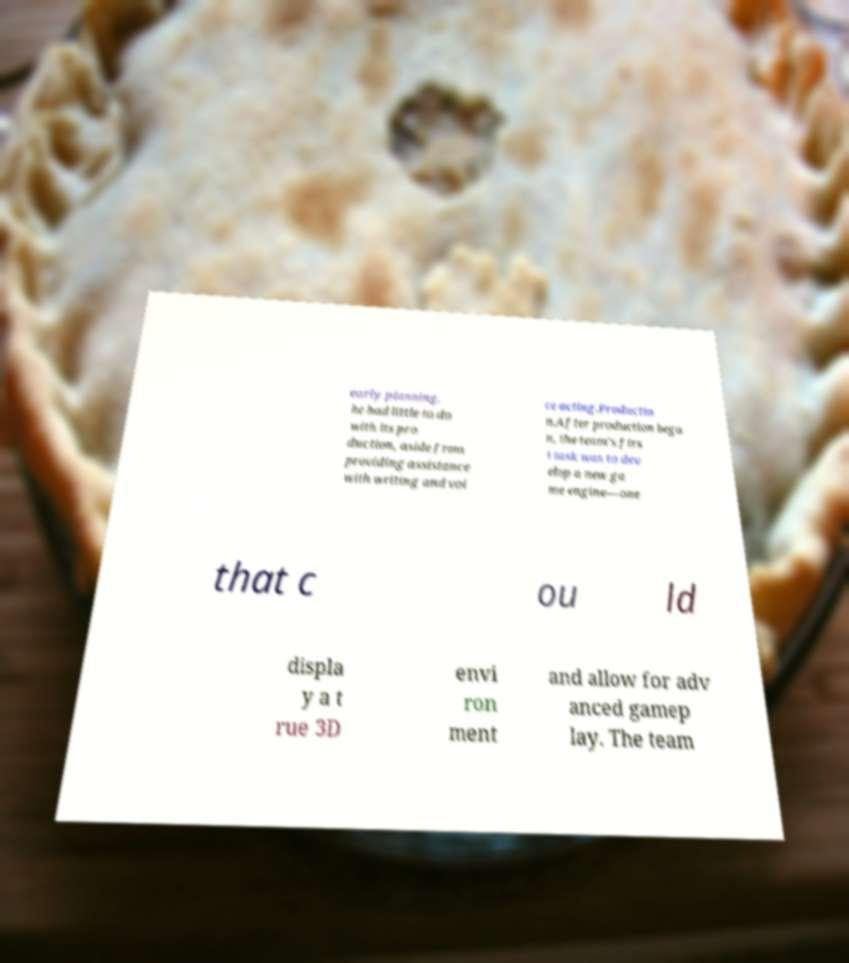Could you extract and type out the text from this image? early planning, he had little to do with its pro duction, aside from providing assistance with writing and voi ce acting.Productio n.After production bega n, the team's firs t task was to dev elop a new ga me engine—one that c ou ld displa y a t rue 3D envi ron ment and allow for adv anced gamep lay. The team 